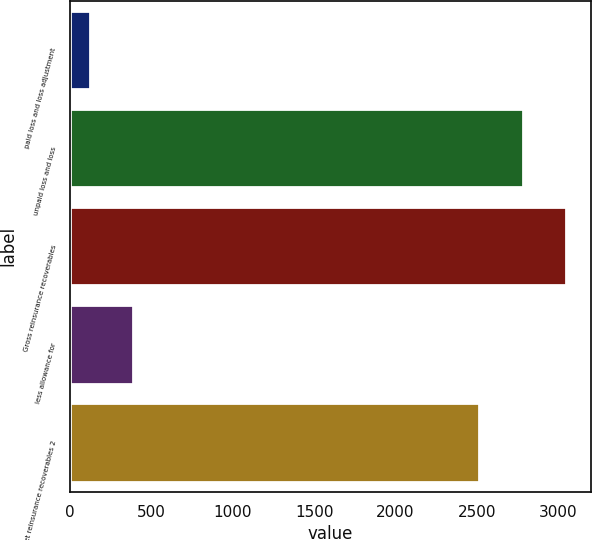Convert chart to OTSL. <chart><loc_0><loc_0><loc_500><loc_500><bar_chart><fcel>paid loss and loss adjustment<fcel>unpaid loss and loss<fcel>Gross reinsurance recoverables<fcel>less allowance for<fcel>Net reinsurance recoverables 2<nl><fcel>119<fcel>2781.2<fcel>3047.4<fcel>385.2<fcel>2515<nl></chart> 